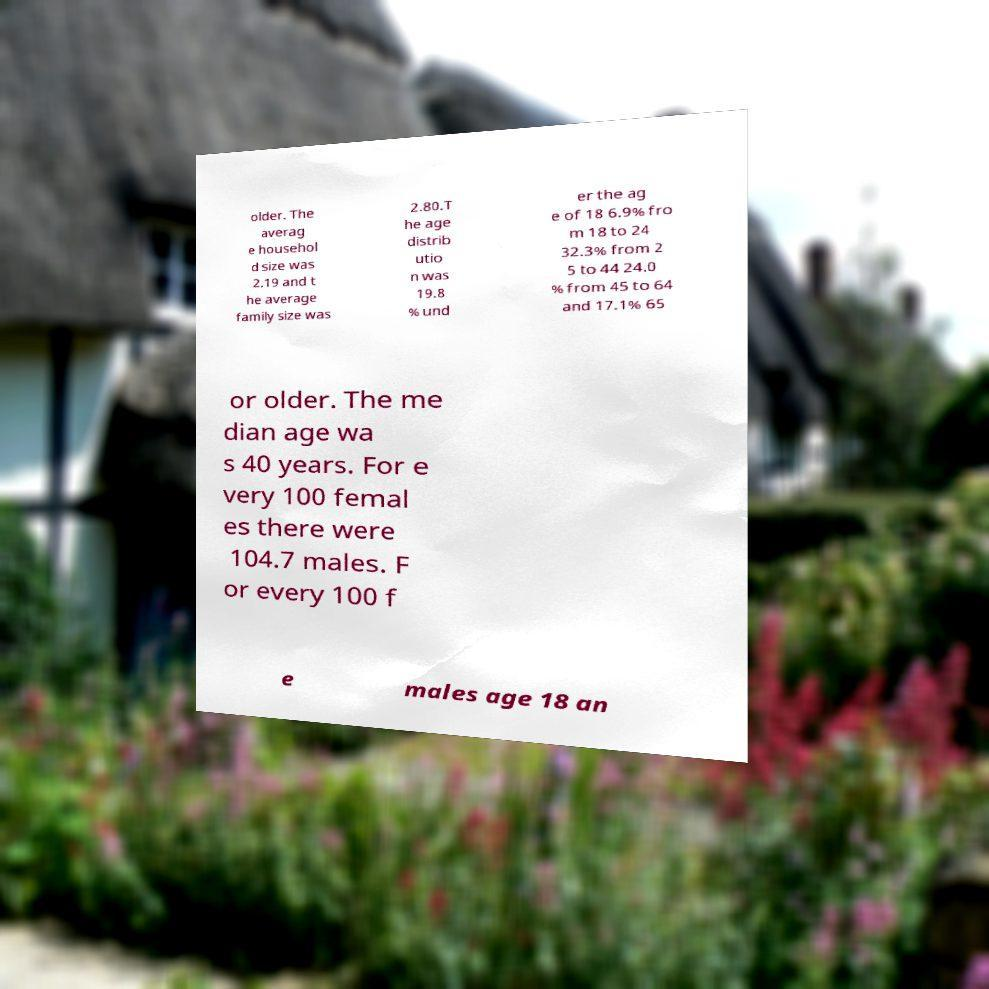There's text embedded in this image that I need extracted. Can you transcribe it verbatim? older. The averag e househol d size was 2.19 and t he average family size was 2.80.T he age distrib utio n was 19.8 % und er the ag e of 18 6.9% fro m 18 to 24 32.3% from 2 5 to 44 24.0 % from 45 to 64 and 17.1% 65 or older. The me dian age wa s 40 years. For e very 100 femal es there were 104.7 males. F or every 100 f e males age 18 an 